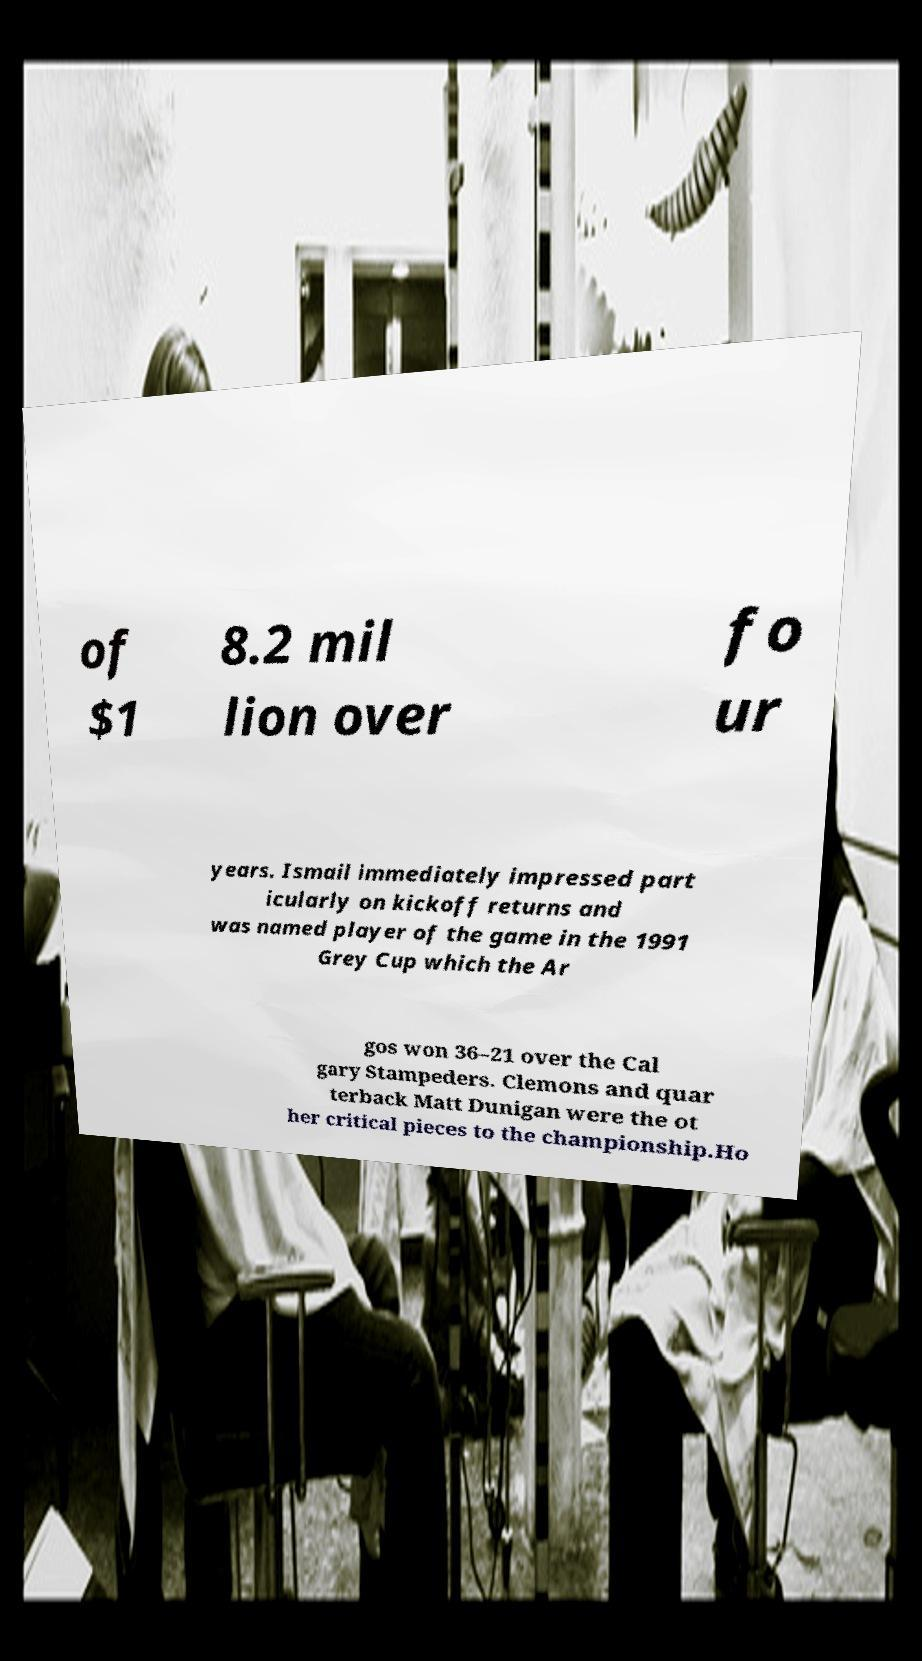Could you assist in decoding the text presented in this image and type it out clearly? of $1 8.2 mil lion over fo ur years. Ismail immediately impressed part icularly on kickoff returns and was named player of the game in the 1991 Grey Cup which the Ar gos won 36–21 over the Cal gary Stampeders. Clemons and quar terback Matt Dunigan were the ot her critical pieces to the championship.Ho 